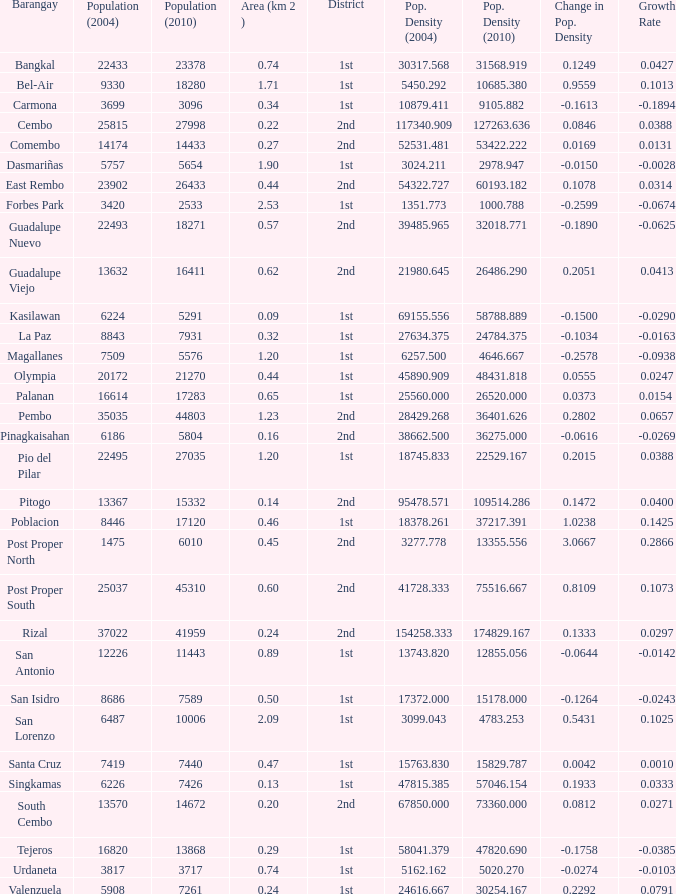What is the area where barangay is guadalupe viejo? 0.62. 